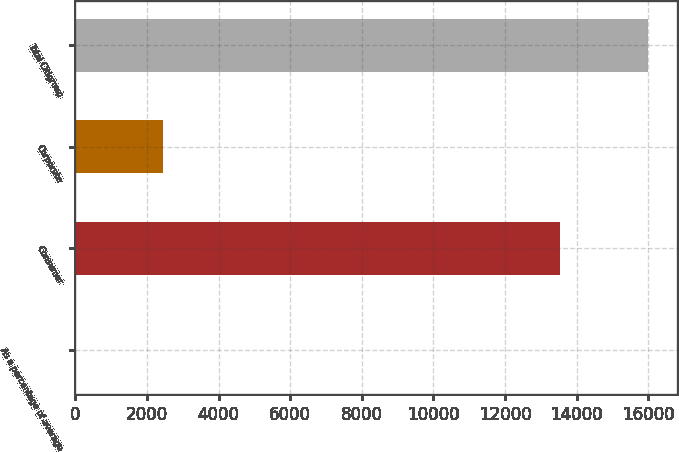Convert chart to OTSL. <chart><loc_0><loc_0><loc_500><loc_500><bar_chart><fcel>As a percentage of average<fcel>Consumer<fcel>Corporate<fcel>Total Citigroup<nl><fcel>0.1<fcel>13547<fcel>2447<fcel>15994<nl></chart> 